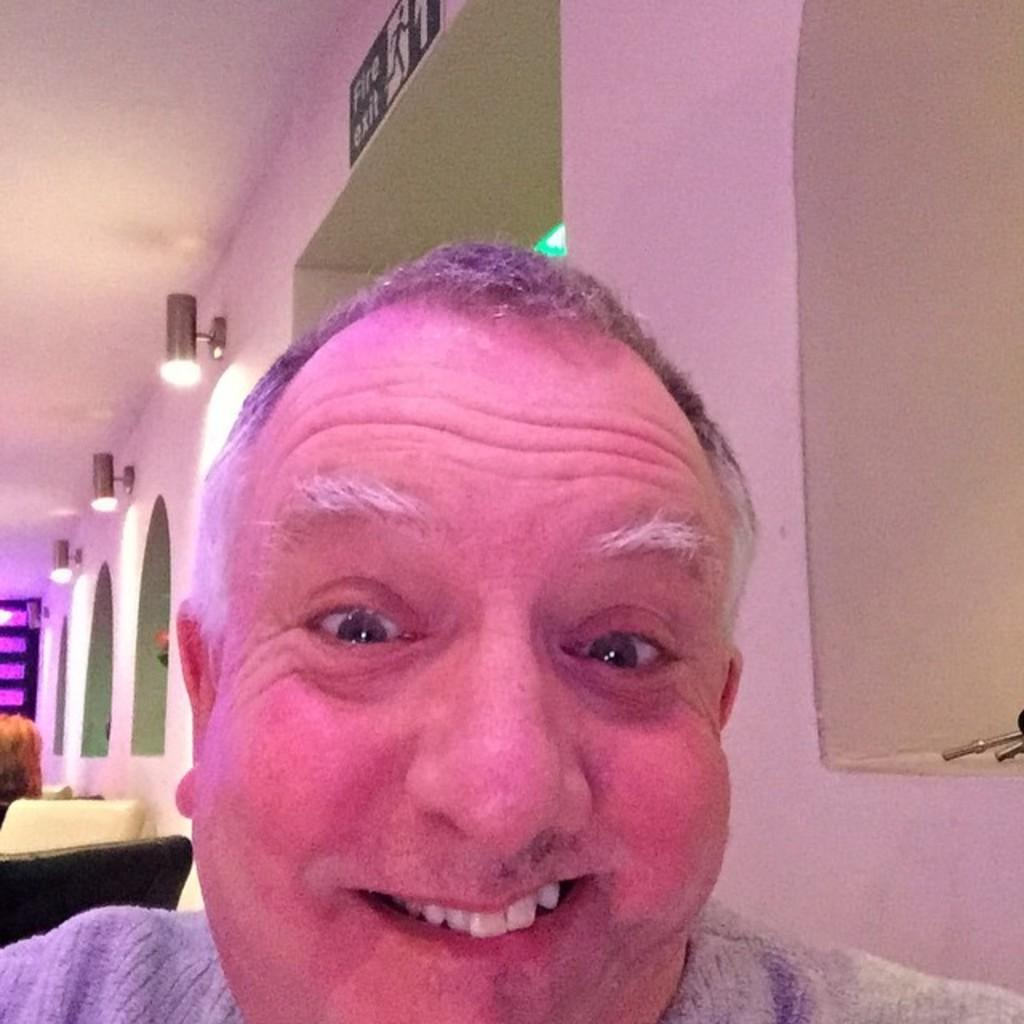Who is present in the image? There is a man in the image. What is the man's facial expression? The man is smiling. What can be seen on the walls and ceiling in the background of the image? There are lights on the wall and ceiling in the background of the image. What else can be seen in the background of the image? There are other objects visible in the background of the image. What type of sponge is being used to clean the silver in the image? There is no sponge or silver present in the image. What record is being played in the background of the image? There is no record player or music being played in the image. 